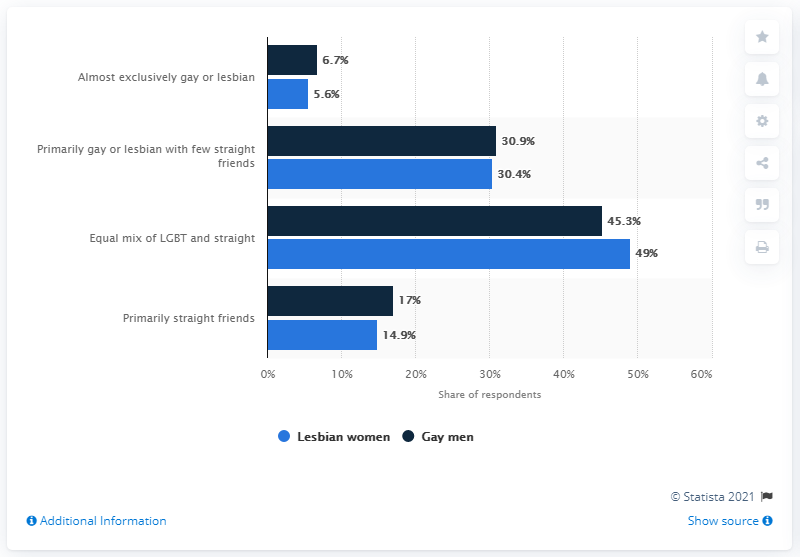List a handful of essential elements in this visual. According to a study, 6.7% of gay men have almost exclusively gay or lesbian friends. It is more likely that gay men have primarily straight friends. 